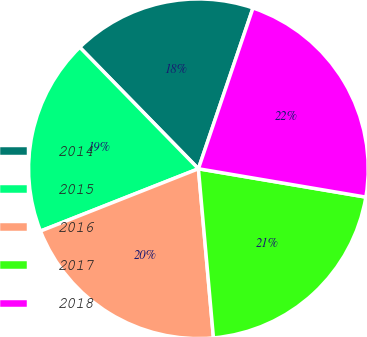<chart> <loc_0><loc_0><loc_500><loc_500><pie_chart><fcel>2014<fcel>2015<fcel>2016<fcel>2017<fcel>2018<nl><fcel>17.52%<fcel>18.67%<fcel>20.43%<fcel>20.92%<fcel>22.46%<nl></chart> 